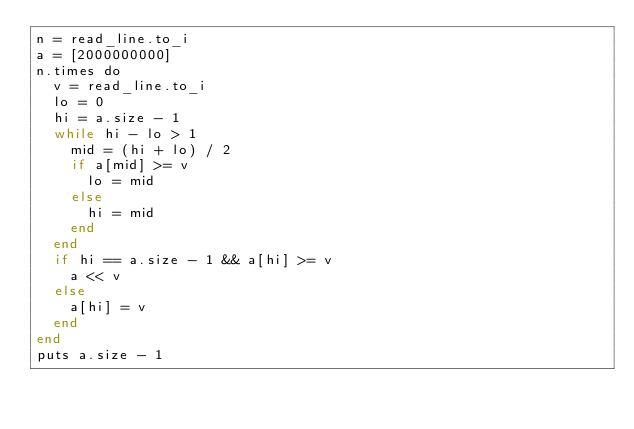<code> <loc_0><loc_0><loc_500><loc_500><_Crystal_>n = read_line.to_i
a = [2000000000]
n.times do
  v = read_line.to_i
  lo = 0
  hi = a.size - 1
  while hi - lo > 1
    mid = (hi + lo) / 2
    if a[mid] >= v
      lo = mid
    else
      hi = mid
    end
  end
  if hi == a.size - 1 && a[hi] >= v
    a << v
  else
    a[hi] = v
  end
end
puts a.size - 1
</code> 